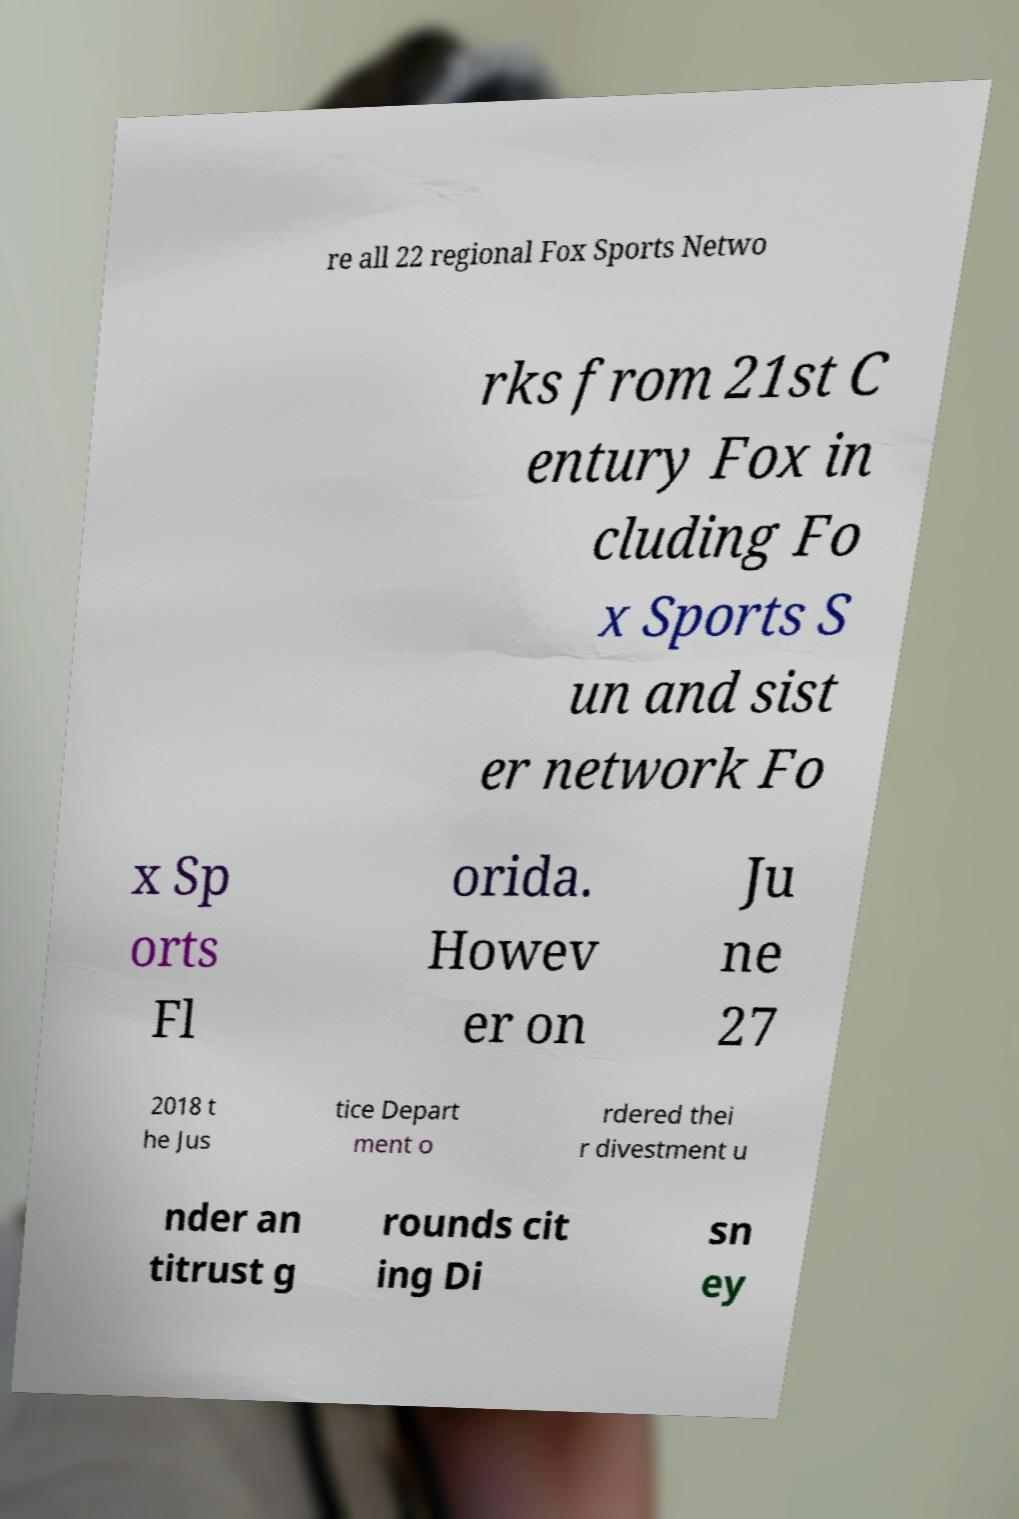What messages or text are displayed in this image? I need them in a readable, typed format. re all 22 regional Fox Sports Netwo rks from 21st C entury Fox in cluding Fo x Sports S un and sist er network Fo x Sp orts Fl orida. Howev er on Ju ne 27 2018 t he Jus tice Depart ment o rdered thei r divestment u nder an titrust g rounds cit ing Di sn ey 